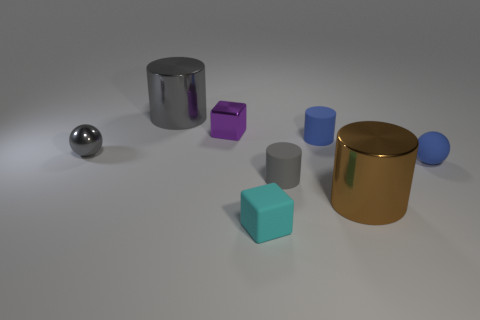Subtract all gray cylinders. How many were subtracted if there are1gray cylinders left? 1 Add 2 small purple cubes. How many objects exist? 10 Subtract all cubes. How many objects are left? 6 Subtract 1 cylinders. How many cylinders are left? 3 Subtract all brown cylinders. Subtract all gray cubes. How many cylinders are left? 3 Subtract all brown blocks. How many blue cylinders are left? 1 Subtract all purple metal blocks. Subtract all small objects. How many objects are left? 1 Add 5 tiny cyan matte blocks. How many tiny cyan matte blocks are left? 6 Add 4 blue rubber cylinders. How many blue rubber cylinders exist? 5 Subtract all blue cylinders. How many cylinders are left? 3 